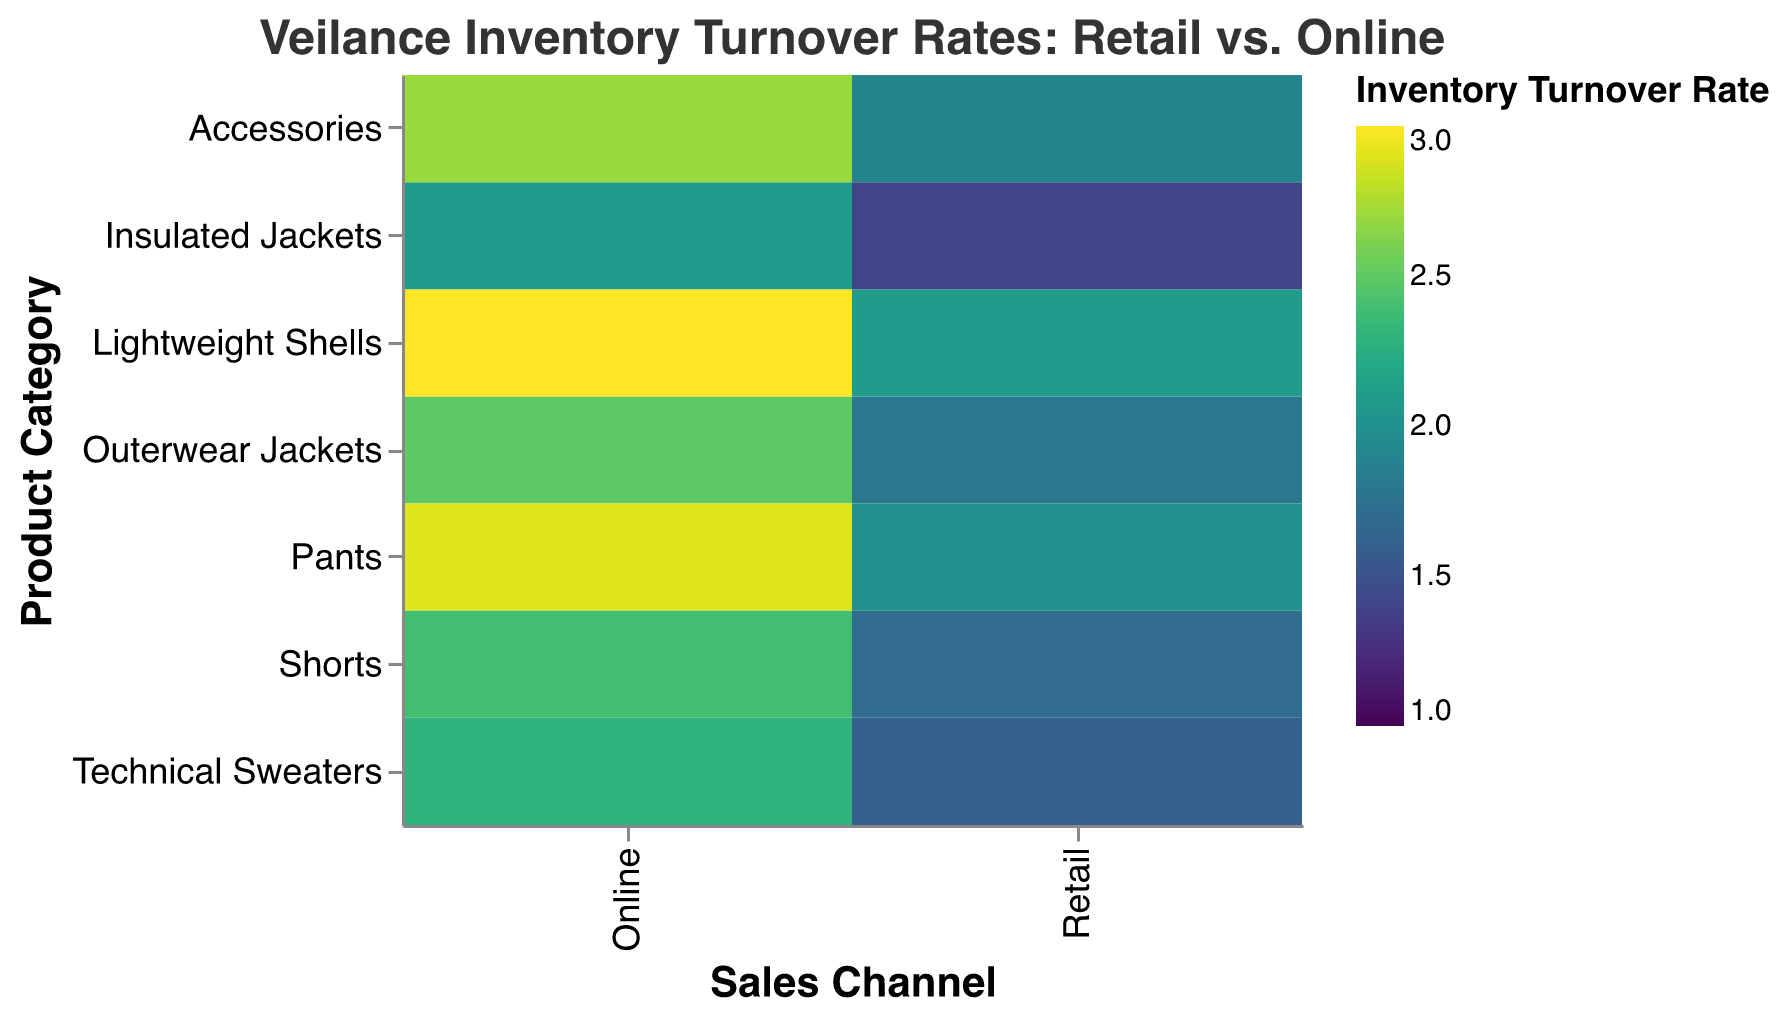Which product category has the highest inventory turnover rate in the retail channel? Look at the Retail column and find the product category with the highest color intensity on the heatmap. Lightweight Shells have the highest turnover rate in the retail channel at 2.1.
Answer: Lightweight Shells Which product categories have an inventory turnover rate higher in the online channel compared to the retail channel? Compare the turnover rates for each product category between the Retail and Online columns. All categories have higher turnover rates online: Outerwear Jackets, Technical Sweaters, Lightweight Shells, Insulated Jackets, Pants, Shorts, Accessories.
Answer: All categories What is the difference in turnover rates for Outerwear Jackets between retail and online channels? Locate the cells for Outerwear Jackets in both Retail and Online columns. Subtract the retail rate (1.8) from the online rate (2.5). The difference is 2.5 - 1.8 = 0.7.
Answer: 0.7 Which product category shows the smallest difference in inventory turnover rates between the retail and online channels? Calculate the difference in turnover rates for each product category: 
- Outerwear Jackets: 2.5 - 1.8 = 0.7
- Technical Sweaters: 2.3 - 1.6 = 0.7
- Lightweight Shells: 3.0 - 2.1 = 0.9
- Insulated Jackets: 2.1 - 1.4 = 0.7
- Pants: 2.9 - 2.0 = 0.9
- Shorts: 2.4 - 1.7 = 0.7
- Accessories: 2.7 - 1.9 = 0.8
The smallest difference is 0.7 and occurs in Outerwear Jackets, Technical Sweaters, Insulated Jackets, and Shorts.
Answer: Outerwear Jackets, Technical Sweaters, Insulated Jackets, Shorts What is the average inventory turnover rate for the online sales channel? Sum all the inventory turnover rates for the Online channel and divide by the number of product categories. The rates are 2.5, 2.3, 3.0, 2.1, 2.9, 2.4, and 2.7. The total is 17.9, and there are 7 product categories, so the average is 17.9 / 7 = 2.56.
Answer: 2.56 